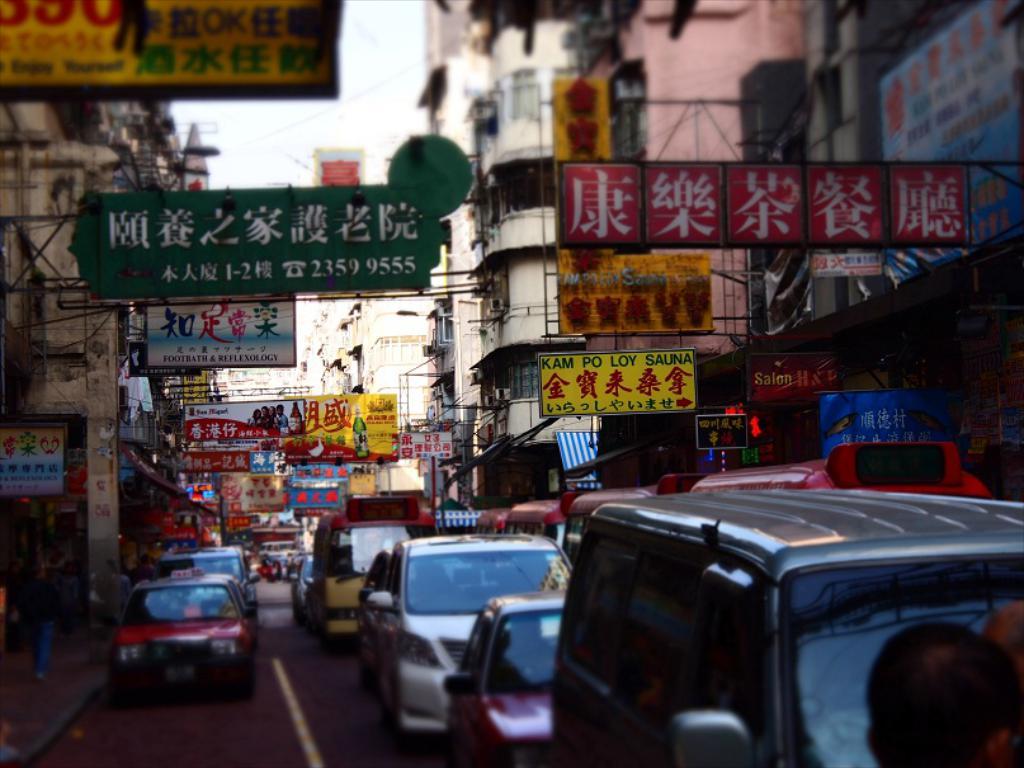What are the last three digits of the telephone number on the sign?
Keep it short and to the point. 555. Are these signs in english?
Offer a terse response. No. 